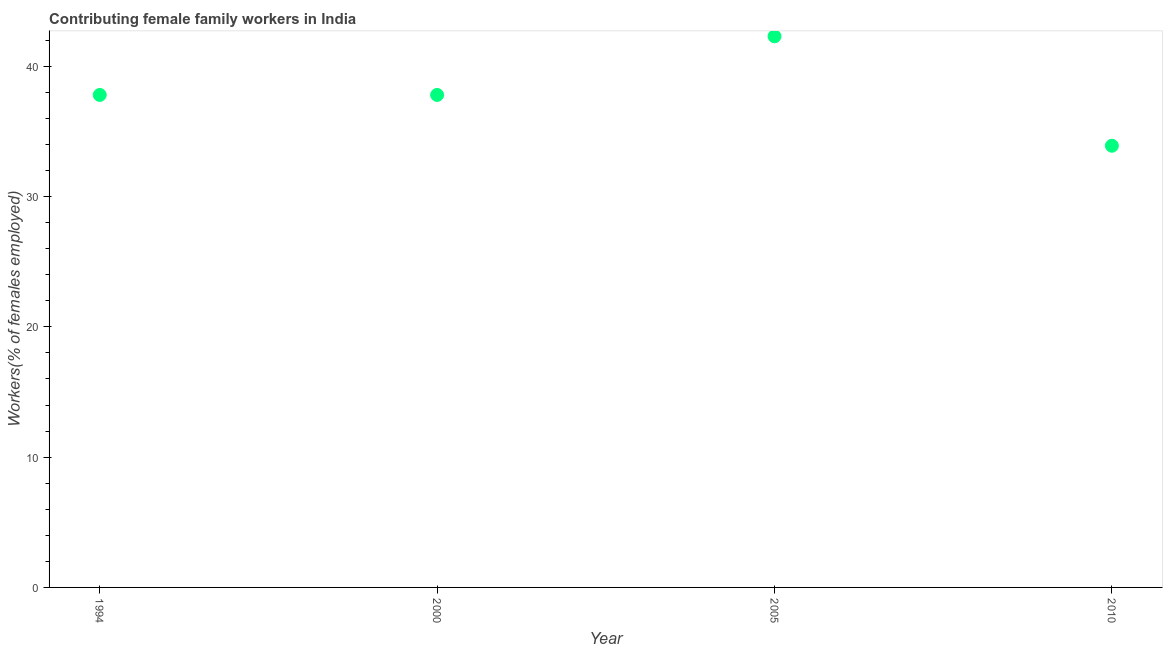What is the contributing female family workers in 2000?
Offer a terse response. 37.8. Across all years, what is the maximum contributing female family workers?
Your response must be concise. 42.3. Across all years, what is the minimum contributing female family workers?
Provide a short and direct response. 33.9. In which year was the contributing female family workers minimum?
Make the answer very short. 2010. What is the sum of the contributing female family workers?
Provide a short and direct response. 151.8. What is the difference between the contributing female family workers in 2005 and 2010?
Offer a terse response. 8.4. What is the average contributing female family workers per year?
Give a very brief answer. 37.95. What is the median contributing female family workers?
Your response must be concise. 37.8. What is the ratio of the contributing female family workers in 1994 to that in 2000?
Offer a terse response. 1. Is the contributing female family workers in 1994 less than that in 2000?
Make the answer very short. No. What is the difference between the highest and the lowest contributing female family workers?
Give a very brief answer. 8.4. What is the difference between two consecutive major ticks on the Y-axis?
Provide a succinct answer. 10. Does the graph contain any zero values?
Offer a very short reply. No. What is the title of the graph?
Keep it short and to the point. Contributing female family workers in India. What is the label or title of the Y-axis?
Keep it short and to the point. Workers(% of females employed). What is the Workers(% of females employed) in 1994?
Ensure brevity in your answer.  37.8. What is the Workers(% of females employed) in 2000?
Offer a very short reply. 37.8. What is the Workers(% of females employed) in 2005?
Your response must be concise. 42.3. What is the Workers(% of females employed) in 2010?
Your response must be concise. 33.9. What is the difference between the Workers(% of females employed) in 2000 and 2010?
Provide a succinct answer. 3.9. What is the difference between the Workers(% of females employed) in 2005 and 2010?
Offer a terse response. 8.4. What is the ratio of the Workers(% of females employed) in 1994 to that in 2000?
Offer a very short reply. 1. What is the ratio of the Workers(% of females employed) in 1994 to that in 2005?
Your answer should be compact. 0.89. What is the ratio of the Workers(% of females employed) in 1994 to that in 2010?
Provide a short and direct response. 1.11. What is the ratio of the Workers(% of females employed) in 2000 to that in 2005?
Make the answer very short. 0.89. What is the ratio of the Workers(% of females employed) in 2000 to that in 2010?
Provide a succinct answer. 1.11. What is the ratio of the Workers(% of females employed) in 2005 to that in 2010?
Provide a short and direct response. 1.25. 